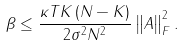<formula> <loc_0><loc_0><loc_500><loc_500>\beta \leq \frac { \kappa T K \left ( N - K \right ) } { 2 \sigma ^ { 2 } N ^ { 2 } } \left \| A \right \| _ { F } ^ { 2 } .</formula> 